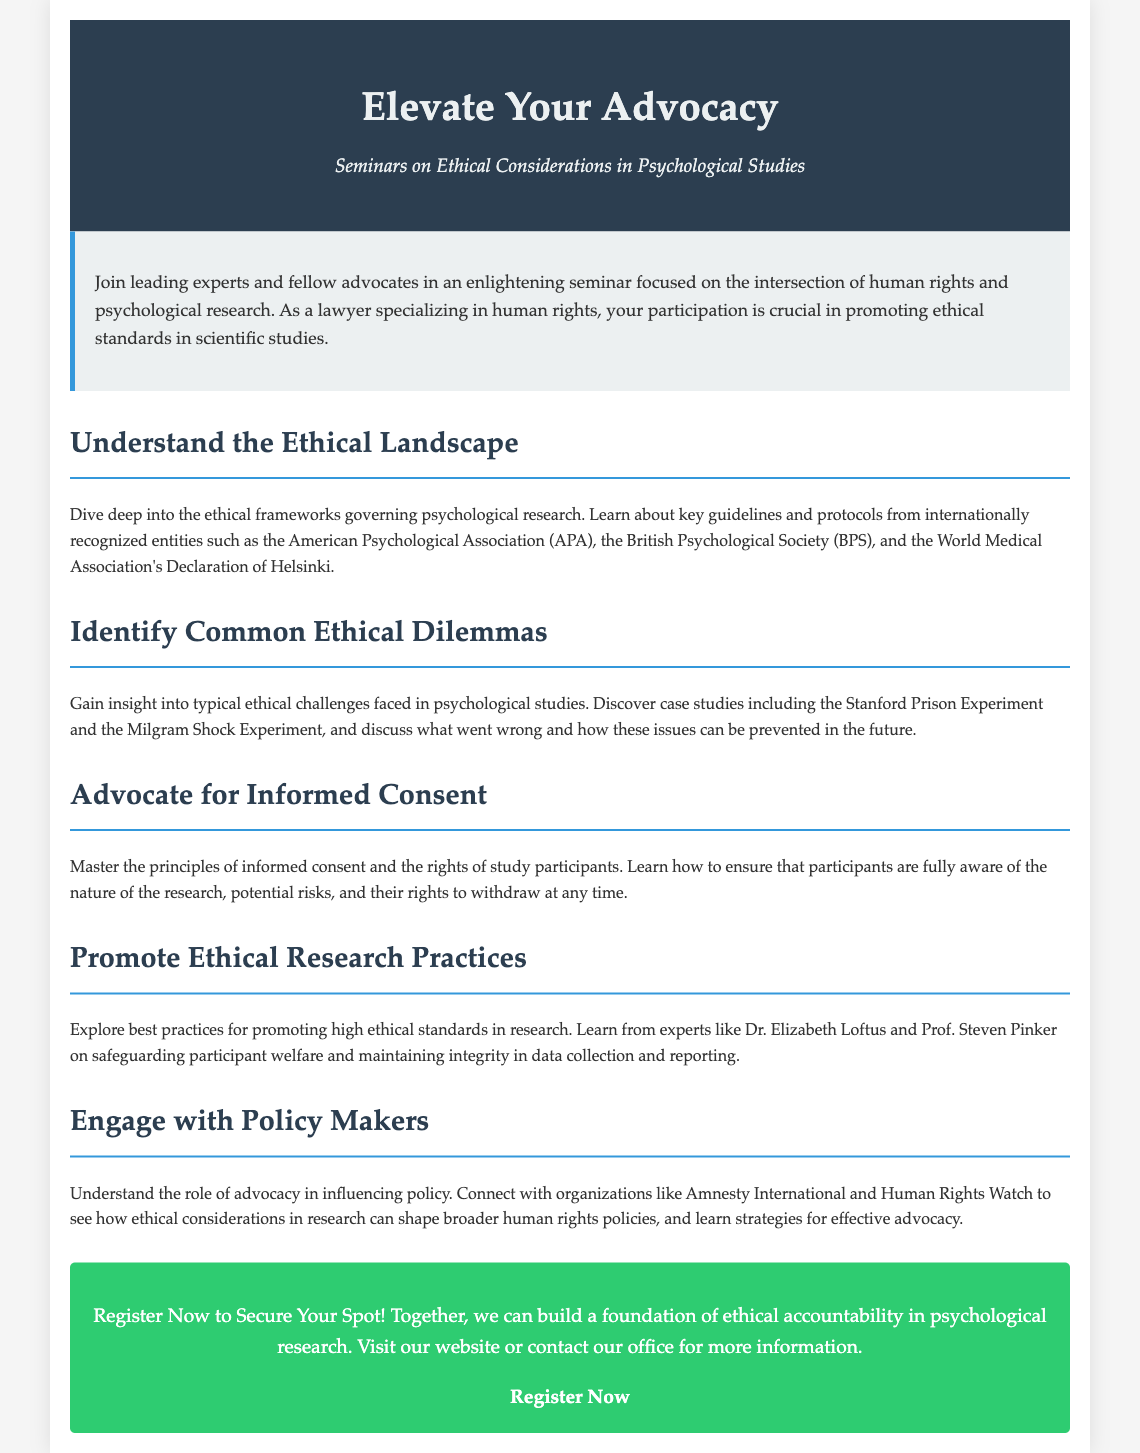What is the main theme of the seminar? The main theme of the seminar is to focus on ethical considerations in psychological studies, particularly from a human rights perspective.
Answer: Ethical considerations in psychological studies Who are the target participants for this seminar? The seminar is aimed at legal professionals, particularly those specializing in human rights issues, and advocates for ethical standards in research.
Answer: Lawyers specializing in human rights Name one expert mentioned in the document. The document provides the names of several experts, including Dr. Elizabeth Loftus and Prof. Steven Pinker.
Answer: Dr. Elizabeth Loftus What does the seminar emphasize regarding study participants? The seminar emphasizes the importance of informed consent and ensuring that participants are aware of their rights during research.
Answer: Informed consent Which organization is referenced in relation to influencing policy? The document mentions organizations like Amnesty International and Human Rights Watch in the context of policy advocacy.
Answer: Amnesty International What type of ethical dilemmas will be examined? The seminar will look at common ethical challenges in psychological studies, including specific case studies.
Answer: Common ethical challenges What is the call to action in the advertisement? The call to action encourages potential participants to register for the seminar to secure their spot.
Answer: Register Now What is the purpose of engaging with policymakers during the seminar? Engaging with policymakers aims to influence broader human rights policies through ethical considerations in research.
Answer: Influencing policy How does the seminar propose to promote ethical research practices? The seminar proposes to explore best practices and learn from experts about maintaining high ethical standards in research.
Answer: Best practices for promoting ethical standards 